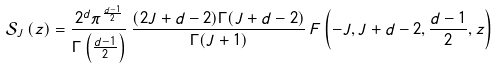<formula> <loc_0><loc_0><loc_500><loc_500>\mathcal { S } _ { J } \left ( z \right ) = \frac { 2 ^ { d } \pi ^ { \frac { d - 1 } { 2 } } } { \Gamma \left ( \frac { d - 1 } { 2 } \right ) } \, \frac { ( 2 J + d - 2 ) \Gamma ( J + d - 2 ) } { \Gamma ( J + 1 ) } \, F \left ( - J , J + d - 2 , \frac { d - 1 } { 2 } , z \right )</formula> 